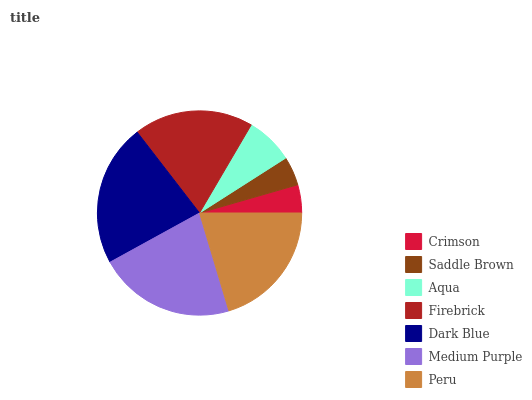Is Crimson the minimum?
Answer yes or no. Yes. Is Dark Blue the maximum?
Answer yes or no. Yes. Is Saddle Brown the minimum?
Answer yes or no. No. Is Saddle Brown the maximum?
Answer yes or no. No. Is Saddle Brown greater than Crimson?
Answer yes or no. Yes. Is Crimson less than Saddle Brown?
Answer yes or no. Yes. Is Crimson greater than Saddle Brown?
Answer yes or no. No. Is Saddle Brown less than Crimson?
Answer yes or no. No. Is Firebrick the high median?
Answer yes or no. Yes. Is Firebrick the low median?
Answer yes or no. Yes. Is Crimson the high median?
Answer yes or no. No. Is Peru the low median?
Answer yes or no. No. 